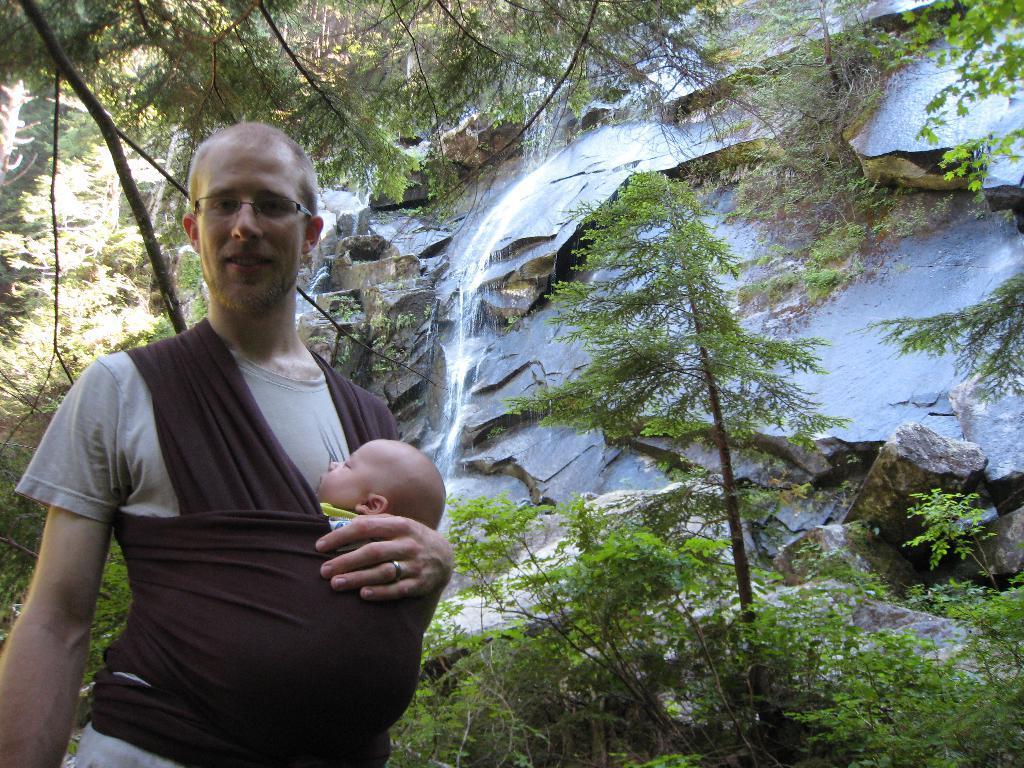How would you summarize this image in a sentence or two? In this image there is a man holding baby with cloth behind him there are trees and waterfall on the rocks. 